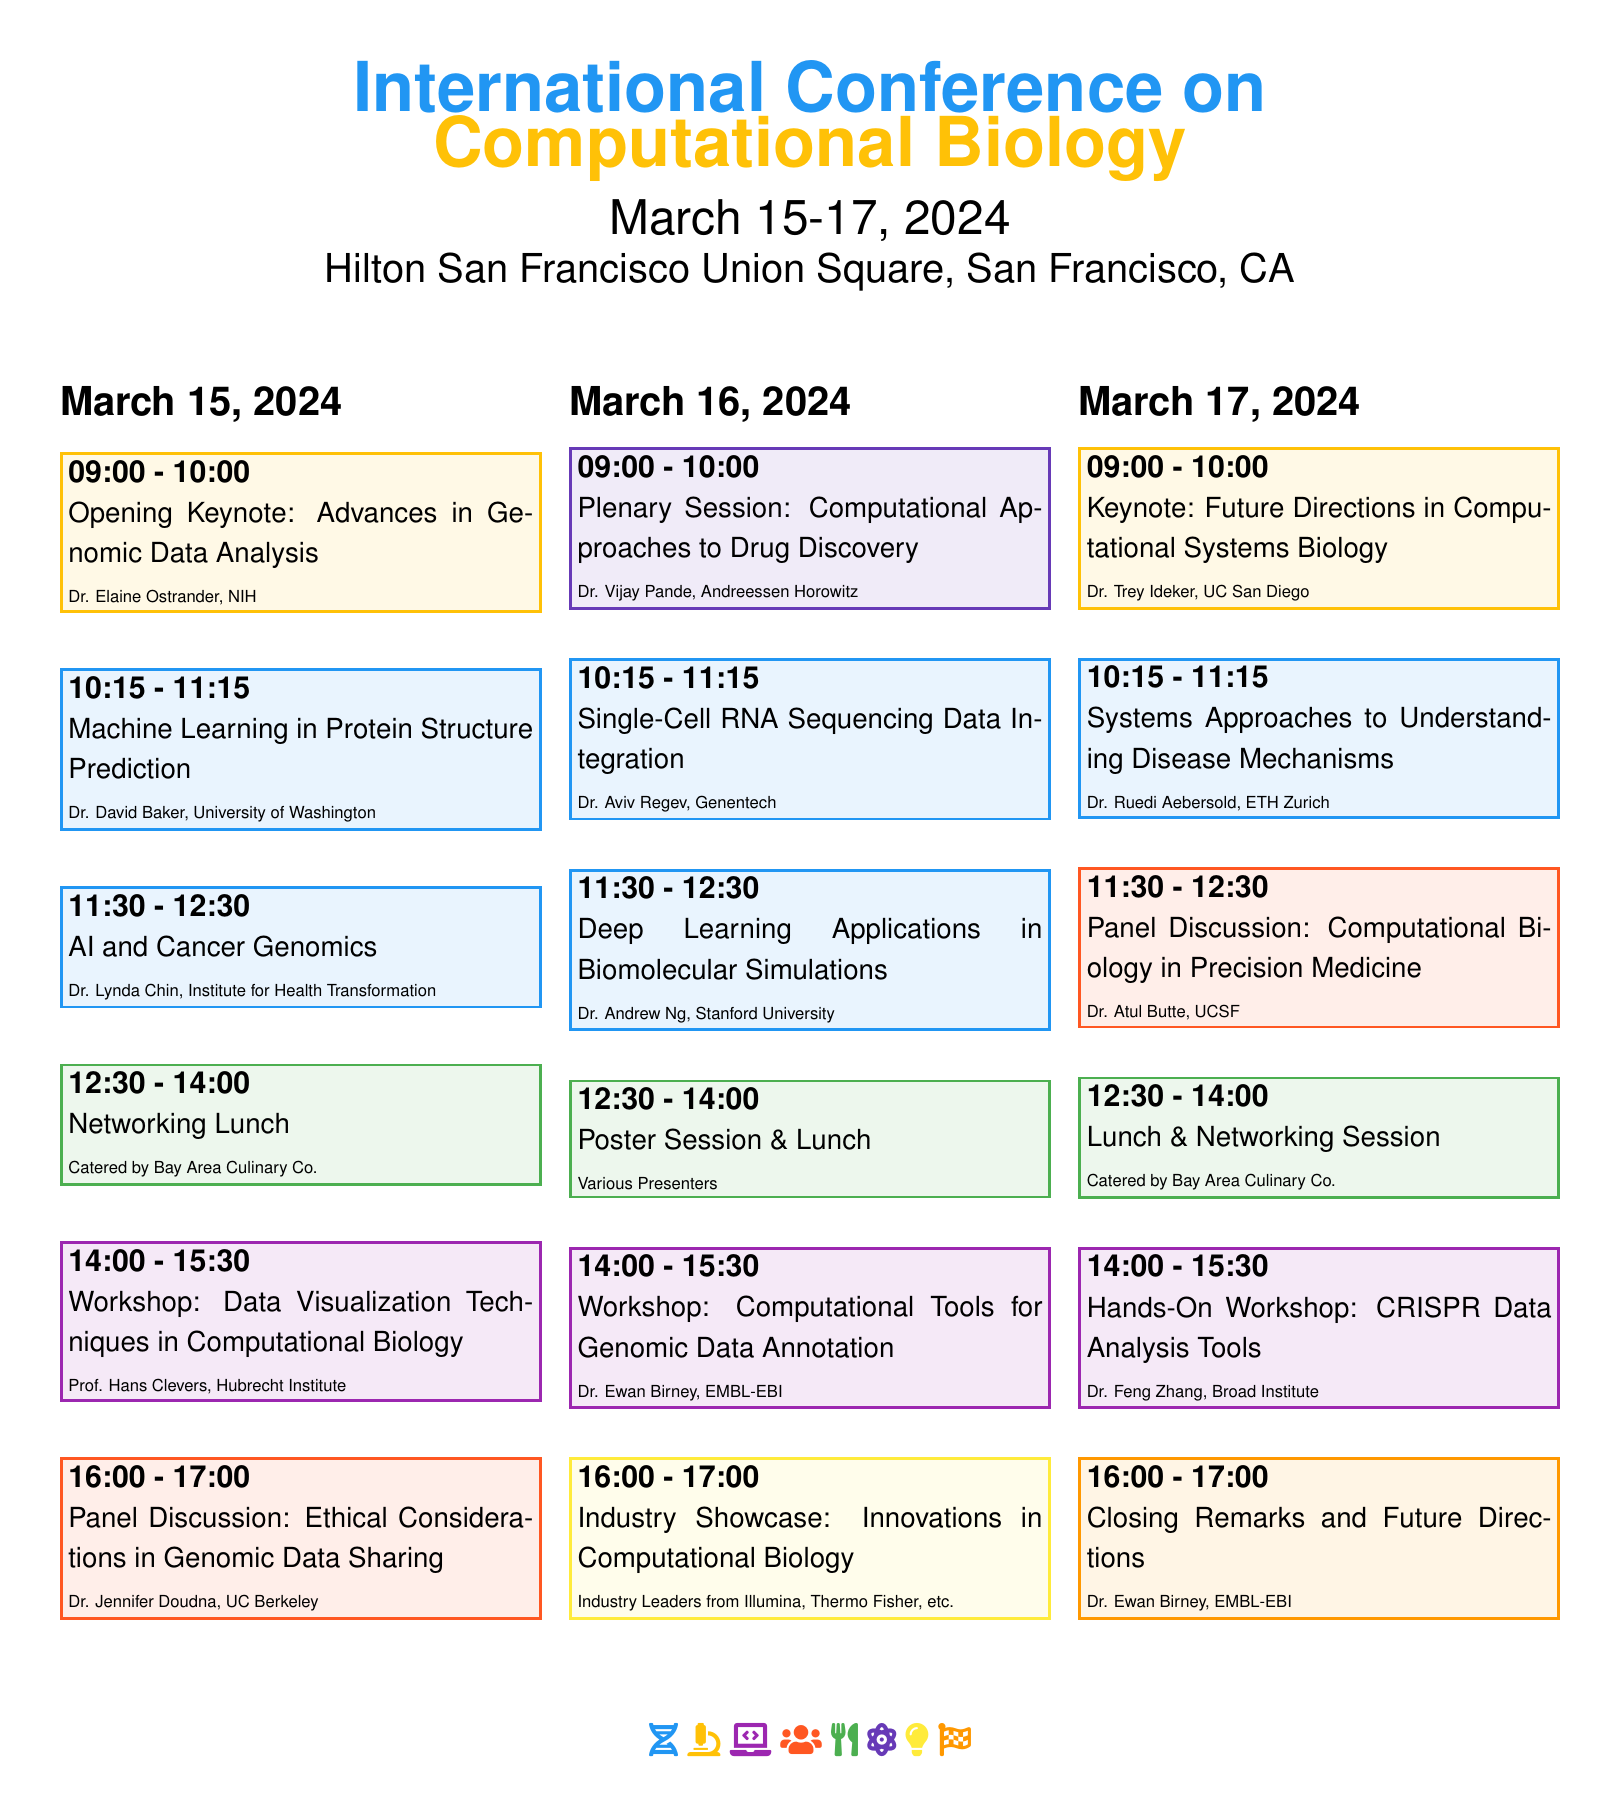What are the dates of the conference? The document states that the conference will take place from March 15 to March 17, 2024.
Answer: March 15-17, 2024 Who is the opening keynote speaker? The opening keynote session lists Dr. Elaine Ostrander from NIH as the speaker.
Answer: Dr. Elaine Ostrander What is the title of the workshop on March 15? The workshop scheduled for March 15 is titled "Data Visualization Techniques in Computational Biology."
Answer: Data Visualization Techniques in Computational Biology How many symposium sessions are scheduled on March 16? On March 16, there are three symposium sessions listed.
Answer: 3 What time does the closing remarks start? The closing remarks are scheduled to start at 16:00 on March 17.
Answer: 16:00 What category does the “Lunch & Networking Session” fall under? The "Lunch & Networking Session" is categorized as a social event in the schedule.
Answer: Social Who will present the panel discussion on March 17? Dr. Atul Butte from UCSF is listed as the presenter for the panel discussion on that day.
Answer: Dr. Atul Butte Which session type appears immediately after the networking lunch on March 15? The session following the networking lunch on March 15 is a workshop.
Answer: Workshop What is the theme of the closing session? The closing session is focused on "Closing Remarks and Future Directions."
Answer: Closing Remarks and Future Directions 